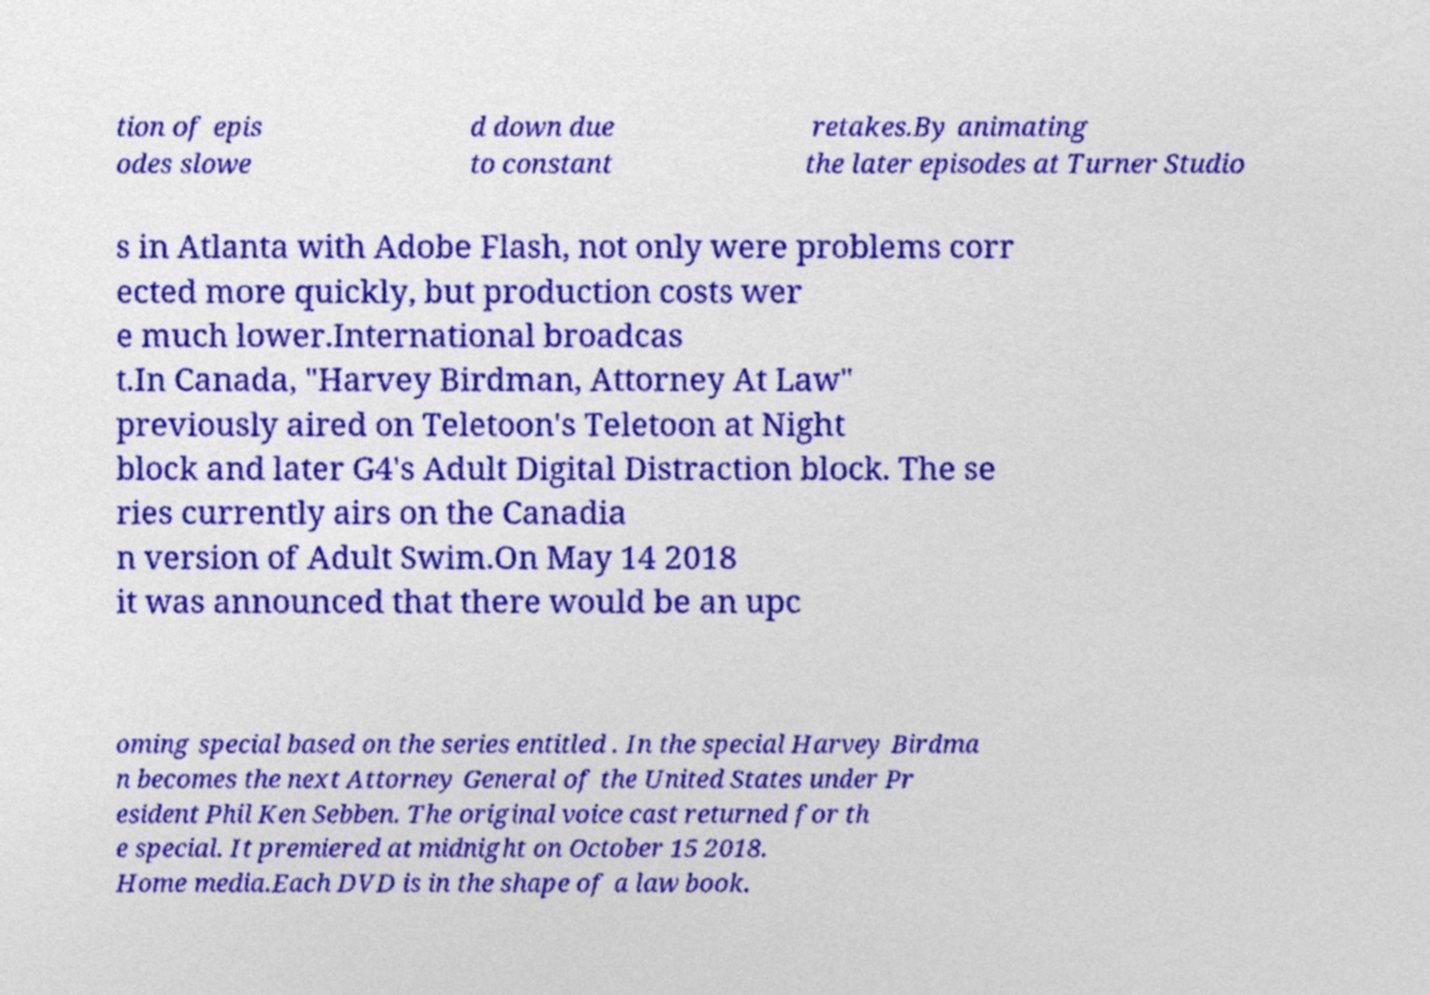There's text embedded in this image that I need extracted. Can you transcribe it verbatim? tion of epis odes slowe d down due to constant retakes.By animating the later episodes at Turner Studio s in Atlanta with Adobe Flash, not only were problems corr ected more quickly, but production costs wer e much lower.International broadcas t.In Canada, "Harvey Birdman, Attorney At Law" previously aired on Teletoon's Teletoon at Night block and later G4's Adult Digital Distraction block. The se ries currently airs on the Canadia n version of Adult Swim.On May 14 2018 it was announced that there would be an upc oming special based on the series entitled . In the special Harvey Birdma n becomes the next Attorney General of the United States under Pr esident Phil Ken Sebben. The original voice cast returned for th e special. It premiered at midnight on October 15 2018. Home media.Each DVD is in the shape of a law book. 